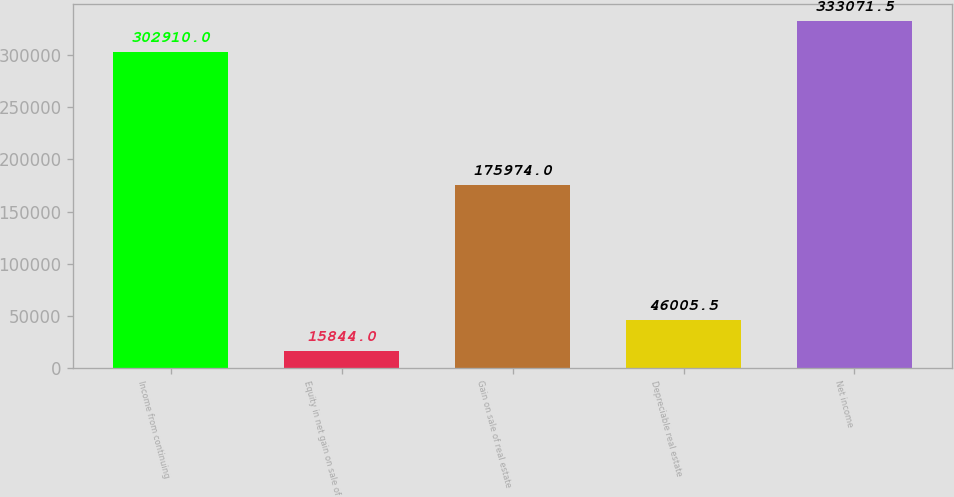Convert chart. <chart><loc_0><loc_0><loc_500><loc_500><bar_chart><fcel>Income from continuing<fcel>Equity in net gain on sale of<fcel>Gain on sale of real estate<fcel>Depreciable real estate<fcel>Net income<nl><fcel>302910<fcel>15844<fcel>175974<fcel>46005.5<fcel>333072<nl></chart> 